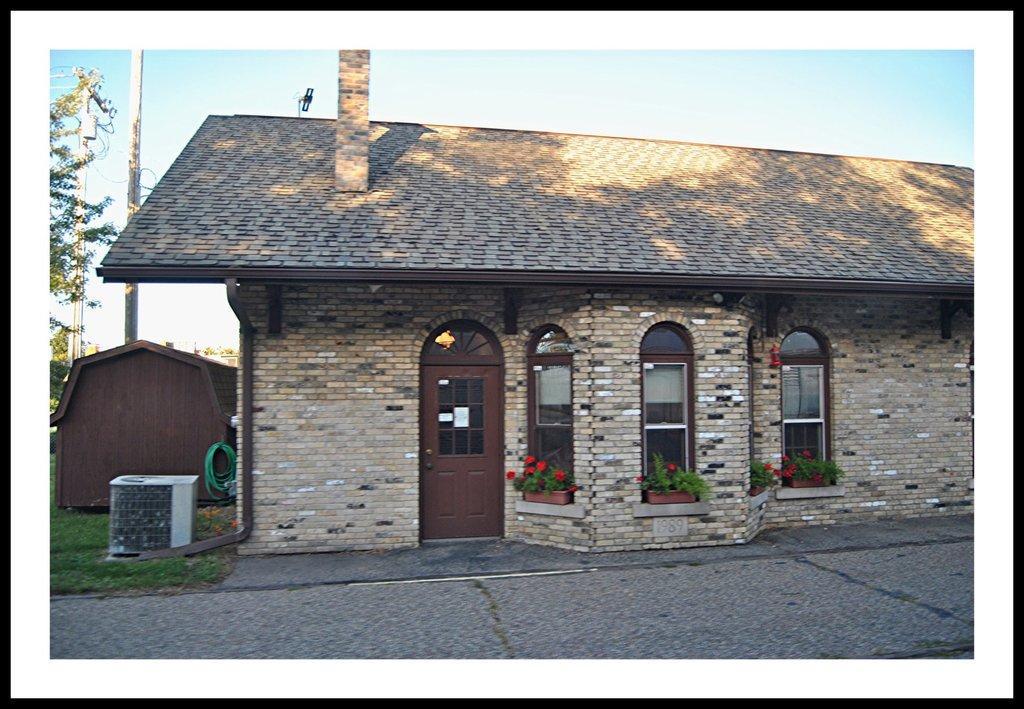Can you describe this image briefly? This is an edited image. It has borders. In the center of the image there is house. There is grass. At the bottom of the image there is floor. At the top of the image there is sky. To the left side of the image there are poles. There is a tree. 